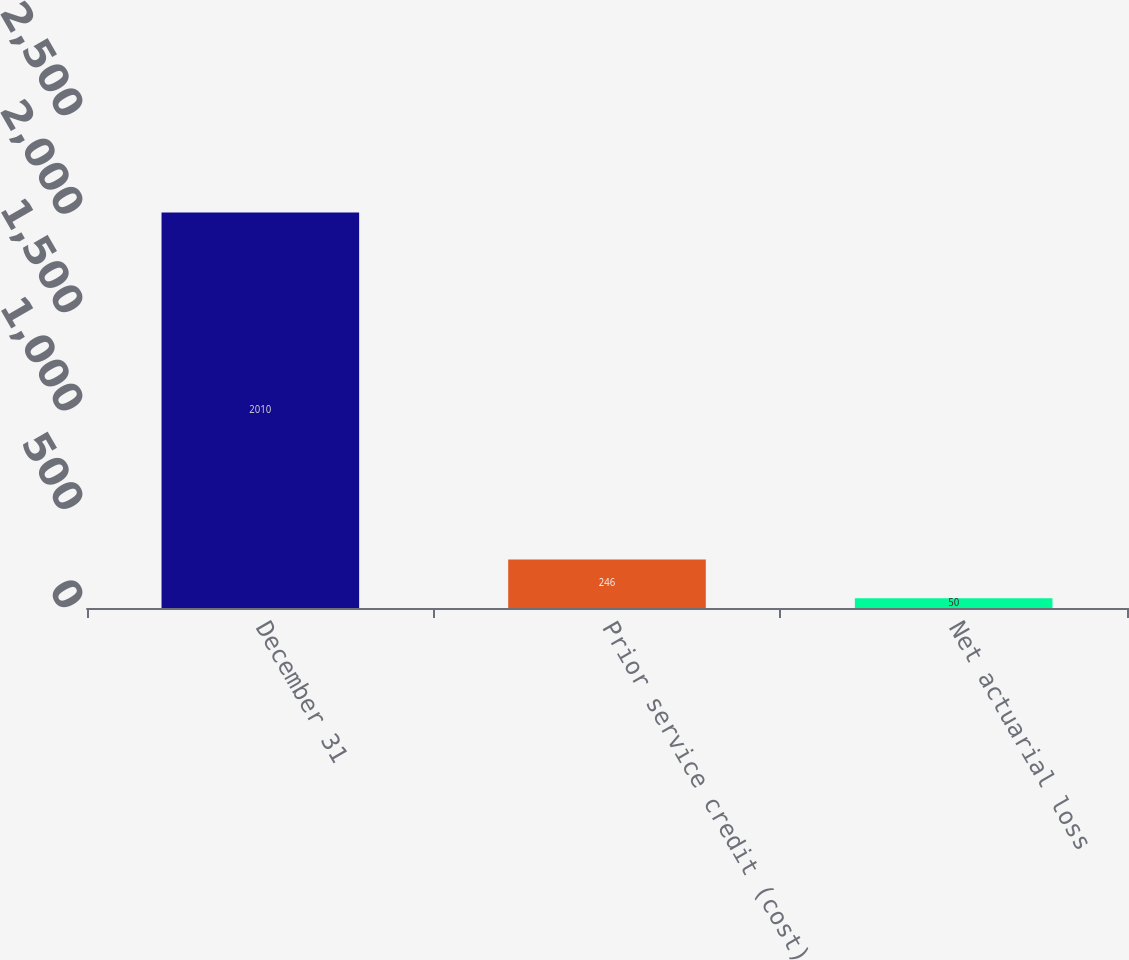<chart> <loc_0><loc_0><loc_500><loc_500><bar_chart><fcel>December 31<fcel>Prior service credit (cost)<fcel>Net actuarial loss<nl><fcel>2010<fcel>246<fcel>50<nl></chart> 